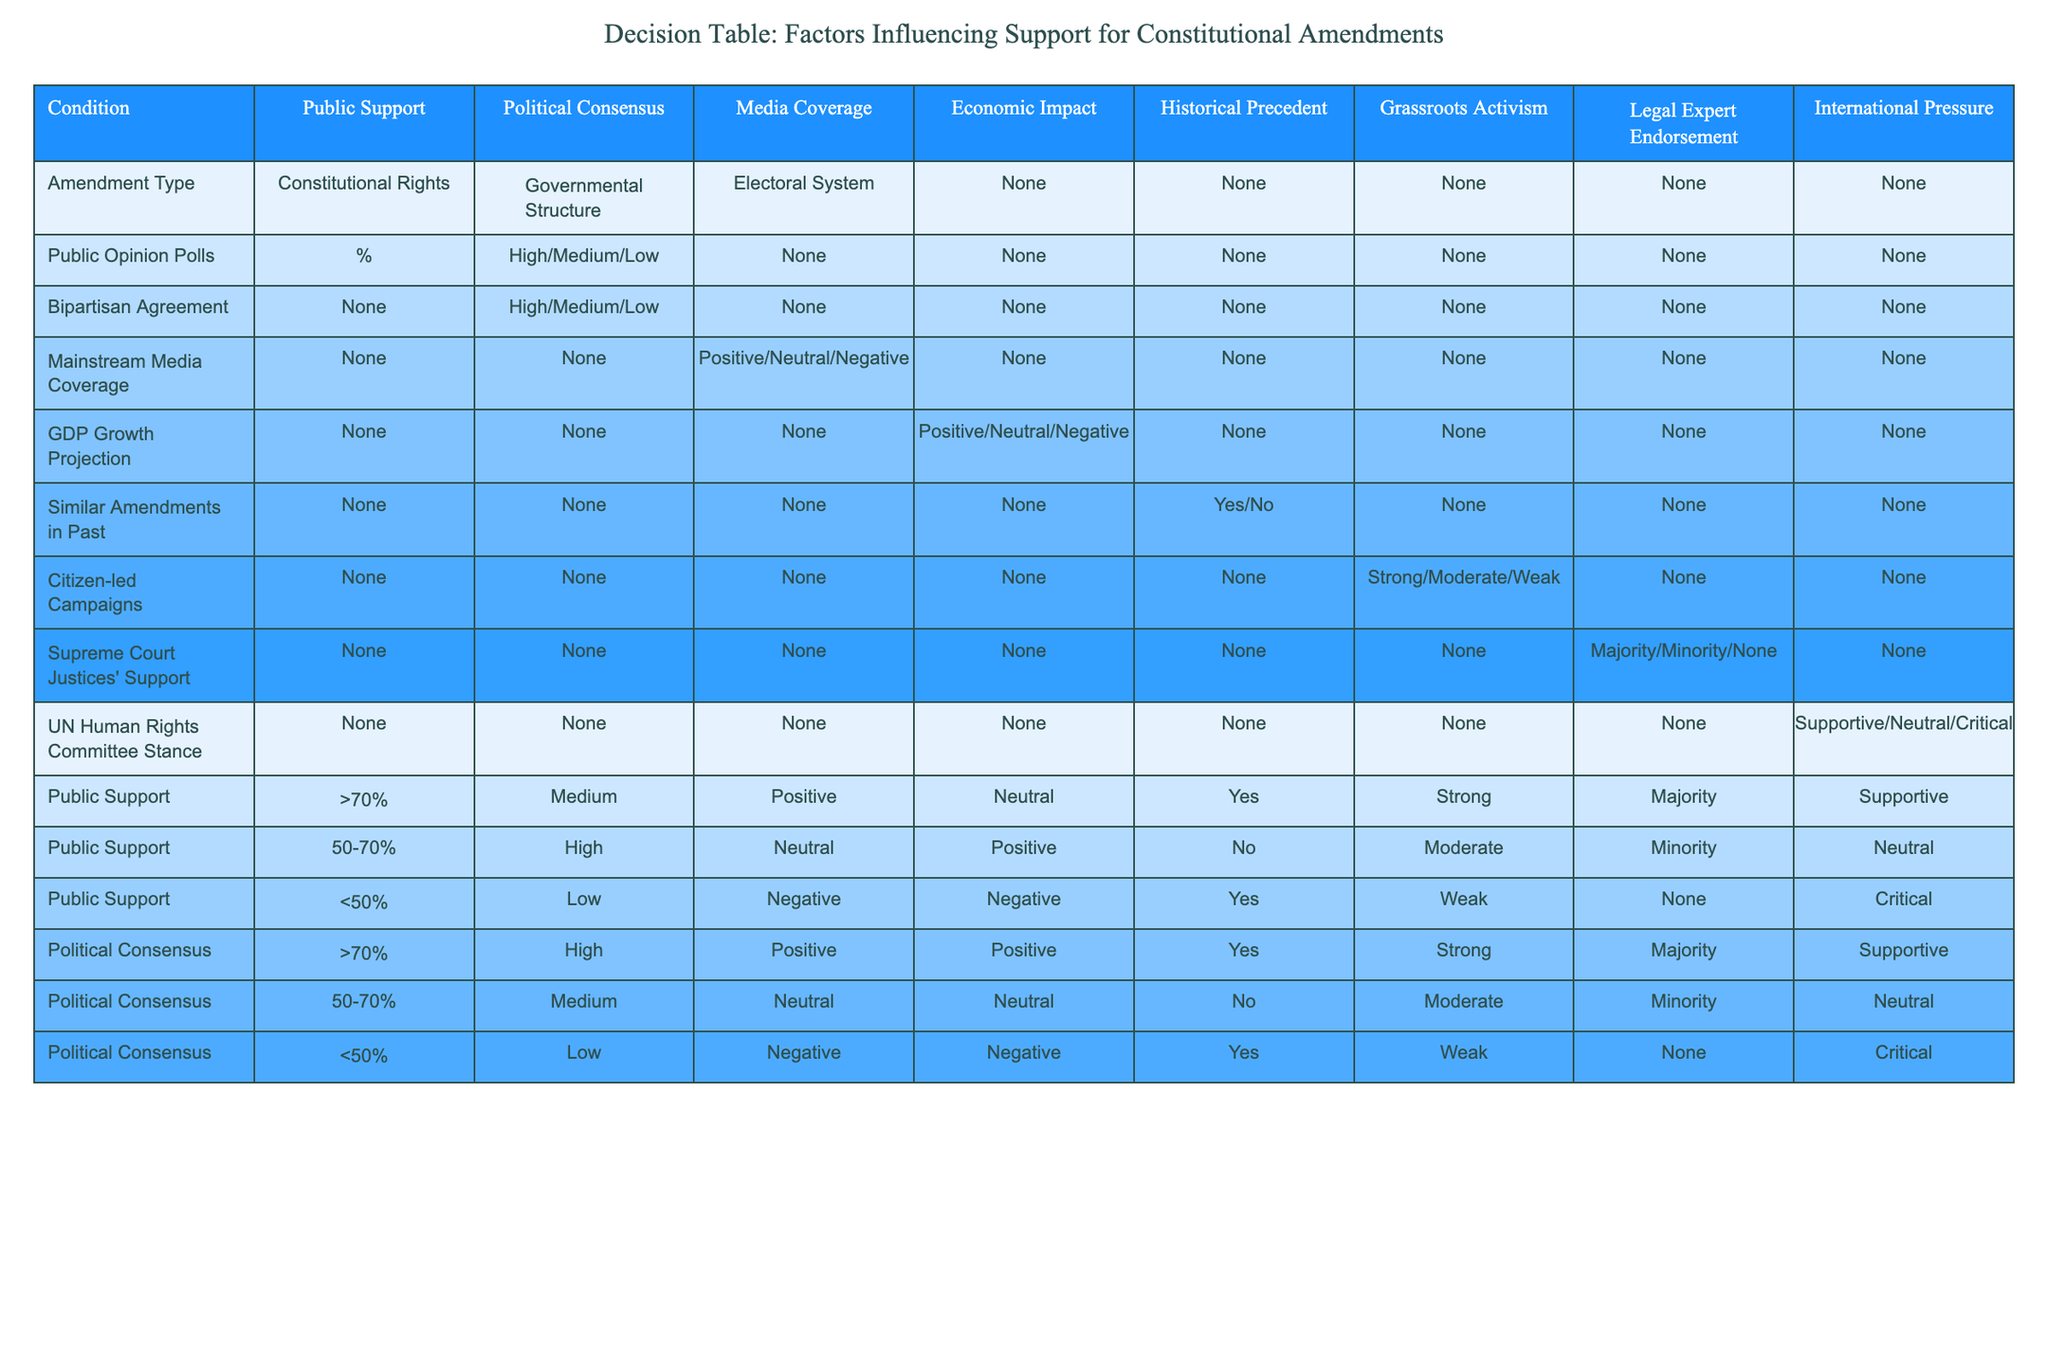What public support level corresponds to high political consensus? Referring to the table, under the category of "Political Consensus," the level of public support corresponding to ">70%" political consensus shows "High" as the public support level.
Answer: High Is there an economic impact when public support is greater than 70%? The table shows that under the condition of public support being ">70%", the economic impact is noted as "Neutral." Therefore, there is no indicated economic impact at that level of support.
Answer: No For which public support level is grassroots activism considered weak? The table indicates that for public support of "<50%", the grassroots activism is described as "Weak." This is evident by locating the public support level in the relevant row.
Answer: <50% What is the majority response from legal experts when political consensus is between 50% and 70%? The data shows that in the row for political consensus of "50-70%", the endorsement from legal experts is listed as "Minority." This signifies that the majority response is not supportive.
Answer: Minority What is the relationship between similar amendments in the past and public support when it is below 50%? Analyzing the table under the row for public support of "<50%", it notes that "Yes" is the presence of similar amendments in the past. Thus, there is indeed a relationship present, as previous amendments influence current support levels even when they are low.
Answer: Yes If bipartisan agreement is high and mainstream media coverage is positive, what is the expected level of public support? To find the expected level of public support, one needs to check the row where bipartisan agreement is marked as "High" and mainstream media coverage is marked as "Positive." This combination indicates that the level of public support would be ">70%."
Answer: >70% Is the UN Human Rights Committee always supportive when public support is low? The table indicates that under the condition of public support being "<50%", the response from the UN Human Rights Committee is "Critical." This suggests that the committee is not supportive at low levels of public support.
Answer: No 